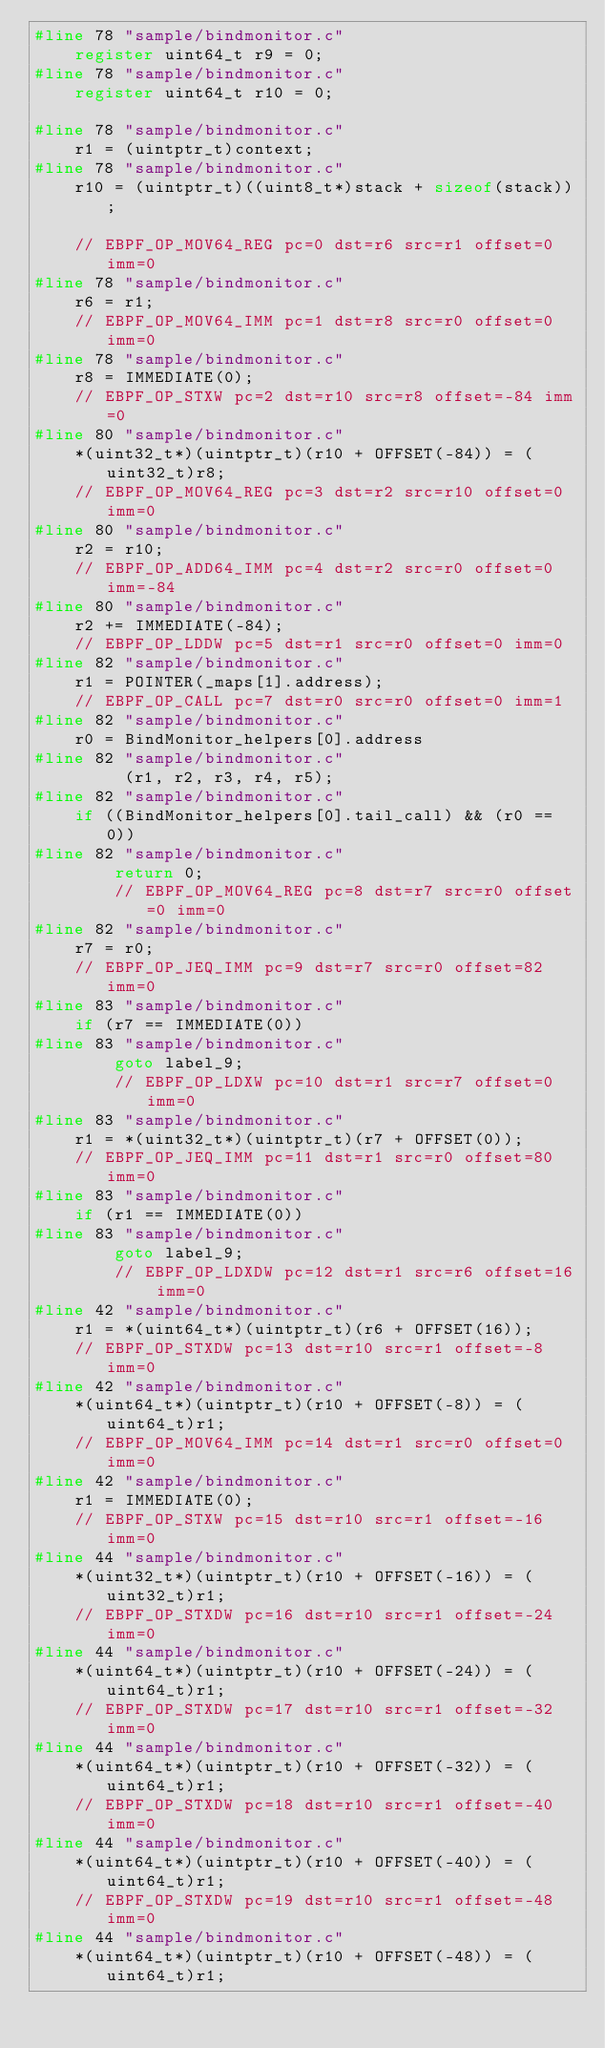Convert code to text. <code><loc_0><loc_0><loc_500><loc_500><_C_>#line 78 "sample/bindmonitor.c"
    register uint64_t r9 = 0;
#line 78 "sample/bindmonitor.c"
    register uint64_t r10 = 0;

#line 78 "sample/bindmonitor.c"
    r1 = (uintptr_t)context;
#line 78 "sample/bindmonitor.c"
    r10 = (uintptr_t)((uint8_t*)stack + sizeof(stack));

    // EBPF_OP_MOV64_REG pc=0 dst=r6 src=r1 offset=0 imm=0
#line 78 "sample/bindmonitor.c"
    r6 = r1;
    // EBPF_OP_MOV64_IMM pc=1 dst=r8 src=r0 offset=0 imm=0
#line 78 "sample/bindmonitor.c"
    r8 = IMMEDIATE(0);
    // EBPF_OP_STXW pc=2 dst=r10 src=r8 offset=-84 imm=0
#line 80 "sample/bindmonitor.c"
    *(uint32_t*)(uintptr_t)(r10 + OFFSET(-84)) = (uint32_t)r8;
    // EBPF_OP_MOV64_REG pc=3 dst=r2 src=r10 offset=0 imm=0
#line 80 "sample/bindmonitor.c"
    r2 = r10;
    // EBPF_OP_ADD64_IMM pc=4 dst=r2 src=r0 offset=0 imm=-84
#line 80 "sample/bindmonitor.c"
    r2 += IMMEDIATE(-84);
    // EBPF_OP_LDDW pc=5 dst=r1 src=r0 offset=0 imm=0
#line 82 "sample/bindmonitor.c"
    r1 = POINTER(_maps[1].address);
    // EBPF_OP_CALL pc=7 dst=r0 src=r0 offset=0 imm=1
#line 82 "sample/bindmonitor.c"
    r0 = BindMonitor_helpers[0].address
#line 82 "sample/bindmonitor.c"
         (r1, r2, r3, r4, r5);
#line 82 "sample/bindmonitor.c"
    if ((BindMonitor_helpers[0].tail_call) && (r0 == 0))
#line 82 "sample/bindmonitor.c"
        return 0;
        // EBPF_OP_MOV64_REG pc=8 dst=r7 src=r0 offset=0 imm=0
#line 82 "sample/bindmonitor.c"
    r7 = r0;
    // EBPF_OP_JEQ_IMM pc=9 dst=r7 src=r0 offset=82 imm=0
#line 83 "sample/bindmonitor.c"
    if (r7 == IMMEDIATE(0))
#line 83 "sample/bindmonitor.c"
        goto label_9;
        // EBPF_OP_LDXW pc=10 dst=r1 src=r7 offset=0 imm=0
#line 83 "sample/bindmonitor.c"
    r1 = *(uint32_t*)(uintptr_t)(r7 + OFFSET(0));
    // EBPF_OP_JEQ_IMM pc=11 dst=r1 src=r0 offset=80 imm=0
#line 83 "sample/bindmonitor.c"
    if (r1 == IMMEDIATE(0))
#line 83 "sample/bindmonitor.c"
        goto label_9;
        // EBPF_OP_LDXDW pc=12 dst=r1 src=r6 offset=16 imm=0
#line 42 "sample/bindmonitor.c"
    r1 = *(uint64_t*)(uintptr_t)(r6 + OFFSET(16));
    // EBPF_OP_STXDW pc=13 dst=r10 src=r1 offset=-8 imm=0
#line 42 "sample/bindmonitor.c"
    *(uint64_t*)(uintptr_t)(r10 + OFFSET(-8)) = (uint64_t)r1;
    // EBPF_OP_MOV64_IMM pc=14 dst=r1 src=r0 offset=0 imm=0
#line 42 "sample/bindmonitor.c"
    r1 = IMMEDIATE(0);
    // EBPF_OP_STXW pc=15 dst=r10 src=r1 offset=-16 imm=0
#line 44 "sample/bindmonitor.c"
    *(uint32_t*)(uintptr_t)(r10 + OFFSET(-16)) = (uint32_t)r1;
    // EBPF_OP_STXDW pc=16 dst=r10 src=r1 offset=-24 imm=0
#line 44 "sample/bindmonitor.c"
    *(uint64_t*)(uintptr_t)(r10 + OFFSET(-24)) = (uint64_t)r1;
    // EBPF_OP_STXDW pc=17 dst=r10 src=r1 offset=-32 imm=0
#line 44 "sample/bindmonitor.c"
    *(uint64_t*)(uintptr_t)(r10 + OFFSET(-32)) = (uint64_t)r1;
    // EBPF_OP_STXDW pc=18 dst=r10 src=r1 offset=-40 imm=0
#line 44 "sample/bindmonitor.c"
    *(uint64_t*)(uintptr_t)(r10 + OFFSET(-40)) = (uint64_t)r1;
    // EBPF_OP_STXDW pc=19 dst=r10 src=r1 offset=-48 imm=0
#line 44 "sample/bindmonitor.c"
    *(uint64_t*)(uintptr_t)(r10 + OFFSET(-48)) = (uint64_t)r1;</code> 